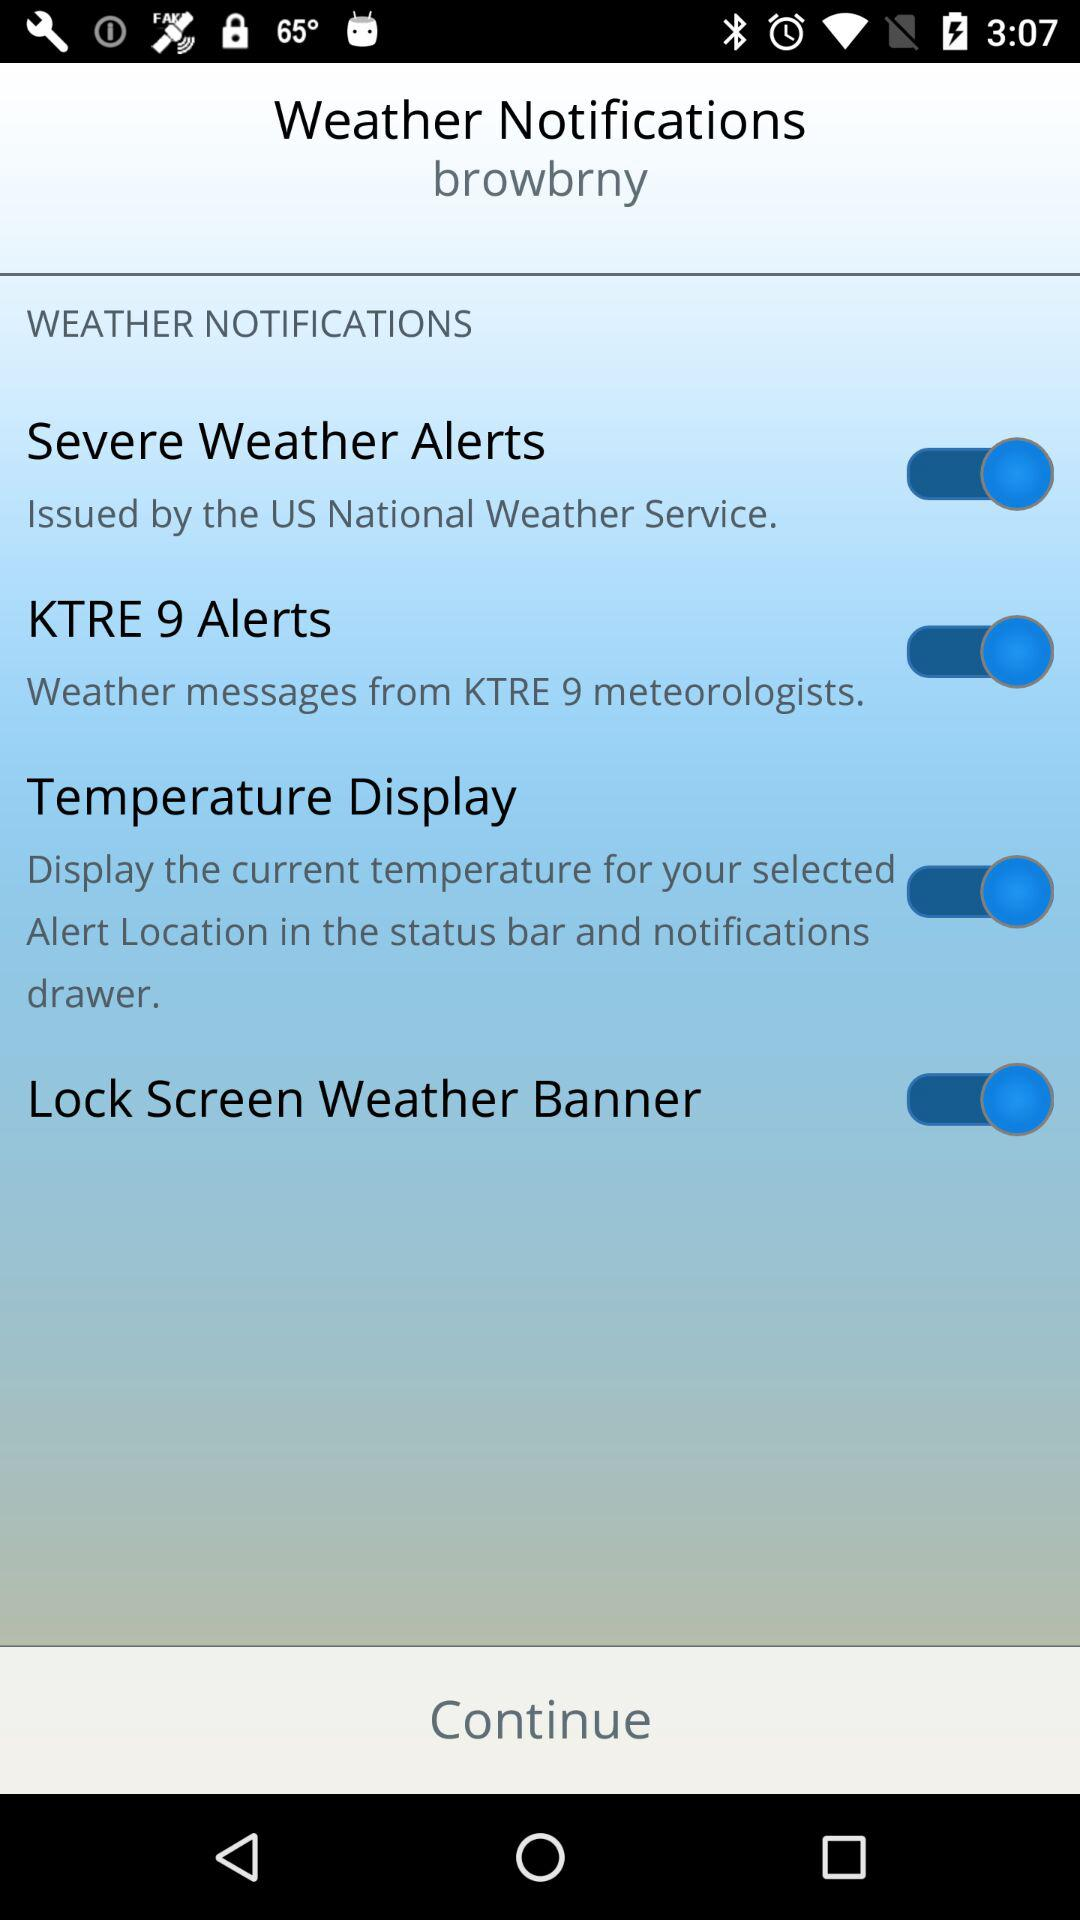What is the current state of Lock screen weather Banner? The status is "on". 